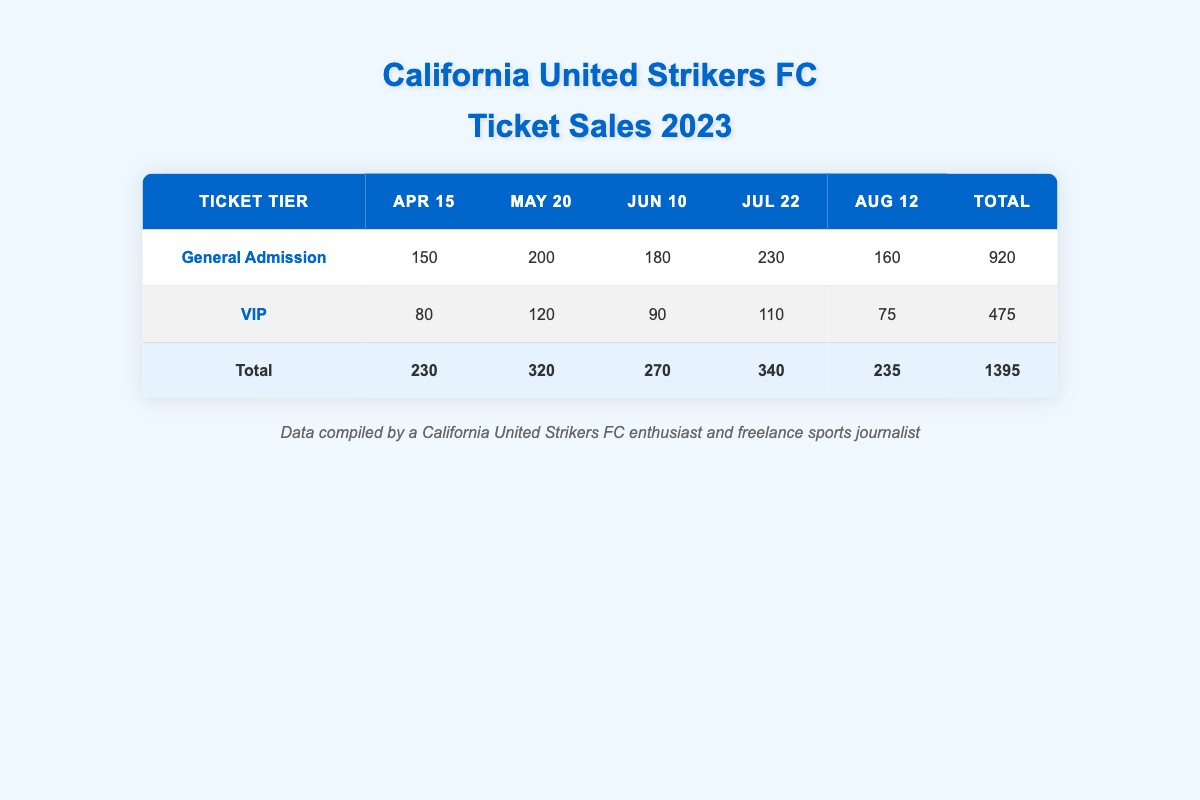What is the total number of tickets sold for General Admission on July 22? According to the table, the number of tickets sold for General Admission on July 22 is 230.
Answer: 230 How many tickets were sold in total across all price tiers for the match on May 20? For May 20, General Admission sold 200 tickets and VIP sold 120 tickets. Adding these gives 200 + 120 = 320.
Answer: 320 Did the California United Strikers FC sell more tickets in General Admission than VIP for all matches combined? Total tickets sold for General Admission is 920, while for VIP it is 475. Since 920 is greater than 475, the answer is yes.
Answer: Yes What is the highest number of tickets sold for a single match? The match on July 22 had the highest number of tickets sold, totaling 230 in General Admission and 110 in VIP, giving 230 + 110 = 340.
Answer: 340 What is the average number of tickets sold for VIP on all match dates? The VIP tickets sold are 80, 120, 90, 110, and 75. Summing these gives 475. There are 5 matches, so the average is 475 / 5 = 95.
Answer: 95 Which match date had the highest total ticket sales? The match on July 22 had a total of 340 tickets sold (230 General Admission + 110 VIP). The other matches had lower totals: 230 for April 15, 320 for May 20, 270 for June 10, and 235 for August 12.
Answer: July 22 How many more tickets were sold in General Admission than in VIP for the entire season? For the entire season, General Admission sold 920 tickets and VIP sold 475 tickets. The difference is 920 - 475 = 445.
Answer: 445 What proportion of the total ticket sales were tickets for VIP? The total tickets sold for all matches is 1395. VIP sales were 475, so the proportion is 475 / 1395 = 0.3403, or about 34.03%.
Answer: 34.03% 